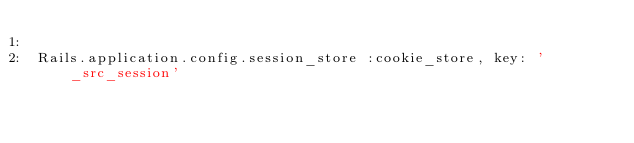<code> <loc_0><loc_0><loc_500><loc_500><_Ruby_>
Rails.application.config.session_store :cookie_store, key: '_src_session'
</code> 